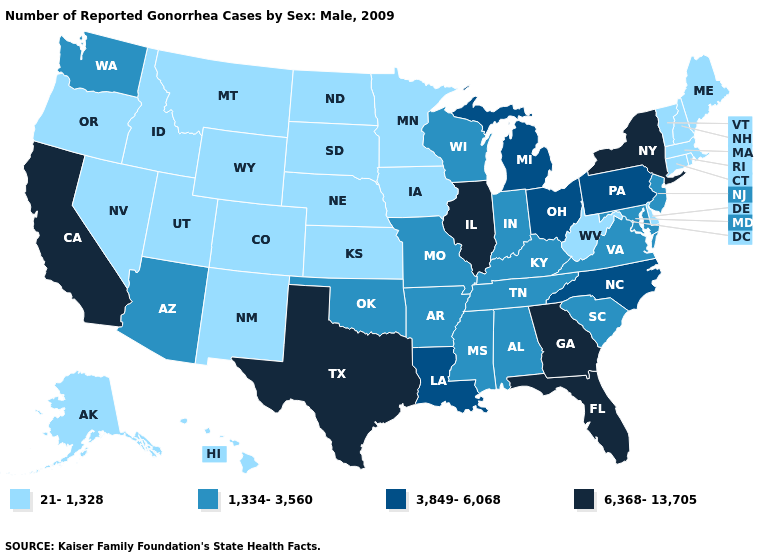Name the states that have a value in the range 3,849-6,068?
Write a very short answer. Louisiana, Michigan, North Carolina, Ohio, Pennsylvania. What is the value of Alaska?
Short answer required. 21-1,328. What is the lowest value in the West?
Be succinct. 21-1,328. Does Missouri have a lower value than Georgia?
Concise answer only. Yes. Which states have the highest value in the USA?
Quick response, please. California, Florida, Georgia, Illinois, New York, Texas. Does Colorado have a lower value than Illinois?
Give a very brief answer. Yes. What is the value of West Virginia?
Write a very short answer. 21-1,328. What is the value of Iowa?
Answer briefly. 21-1,328. Name the states that have a value in the range 21-1,328?
Short answer required. Alaska, Colorado, Connecticut, Delaware, Hawaii, Idaho, Iowa, Kansas, Maine, Massachusetts, Minnesota, Montana, Nebraska, Nevada, New Hampshire, New Mexico, North Dakota, Oregon, Rhode Island, South Dakota, Utah, Vermont, West Virginia, Wyoming. Among the states that border Nebraska , does Wyoming have the highest value?
Quick response, please. No. What is the lowest value in the USA?
Concise answer only. 21-1,328. Does Ohio have a higher value than New Jersey?
Write a very short answer. Yes. What is the value of Rhode Island?
Give a very brief answer. 21-1,328. Among the states that border New Mexico , which have the lowest value?
Concise answer only. Colorado, Utah. 